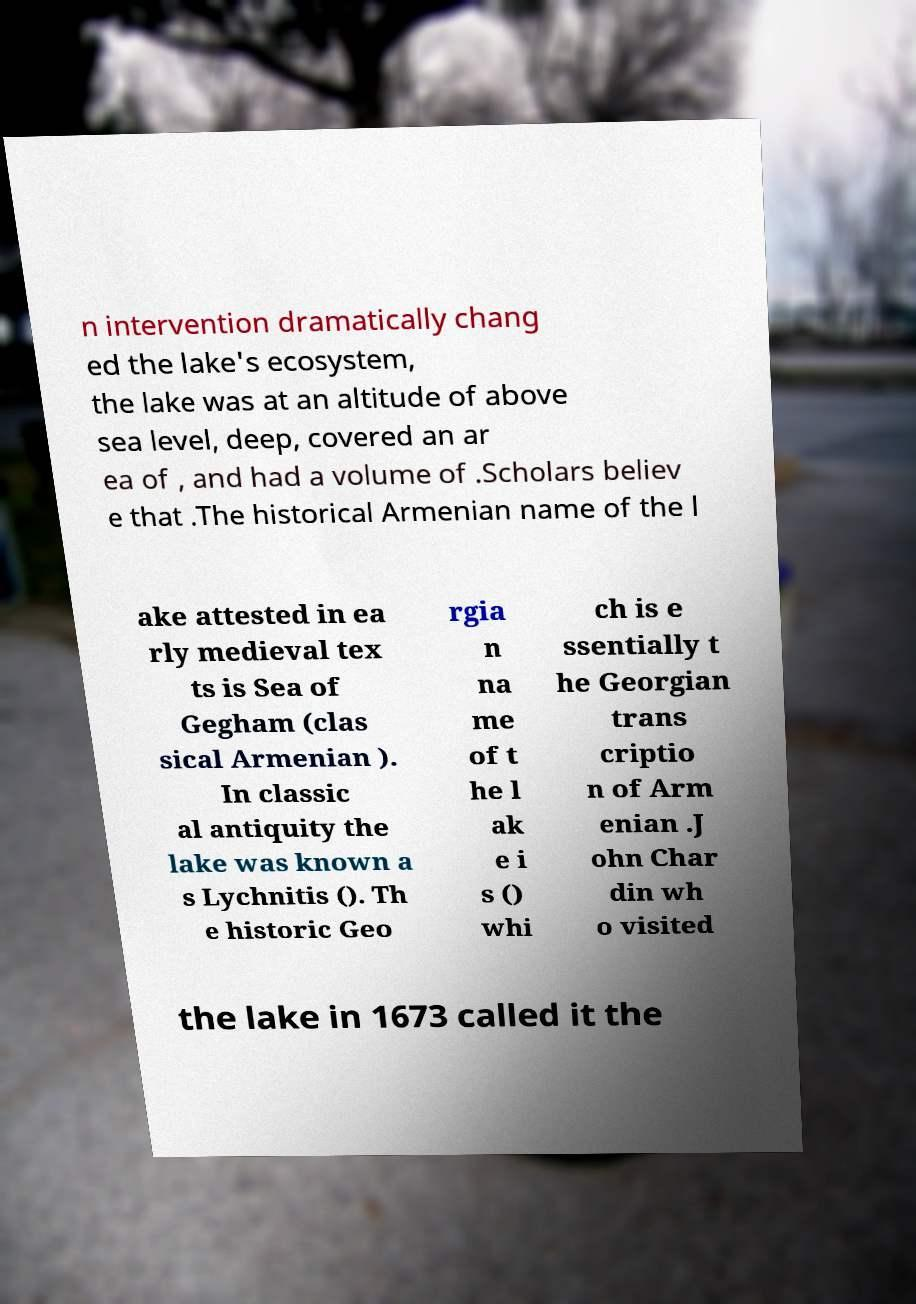For documentation purposes, I need the text within this image transcribed. Could you provide that? n intervention dramatically chang ed the lake's ecosystem, the lake was at an altitude of above sea level, deep, covered an ar ea of , and had a volume of .Scholars believ e that .The historical Armenian name of the l ake attested in ea rly medieval tex ts is Sea of Gegham (clas sical Armenian ). In classic al antiquity the lake was known a s Lychnitis (). Th e historic Geo rgia n na me of t he l ak e i s () whi ch is e ssentially t he Georgian trans criptio n of Arm enian .J ohn Char din wh o visited the lake in 1673 called it the 